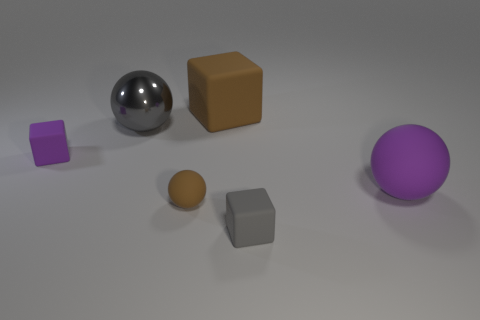Is the big object in front of the big gray sphere made of the same material as the gray thing that is in front of the big gray object?
Your answer should be compact. Yes. There is a tiny block to the right of the small cube on the left side of the small brown rubber ball; what is its material?
Your answer should be very brief. Rubber. What is the shape of the brown object behind the small rubber cube that is to the left of the block to the right of the big brown rubber cube?
Ensure brevity in your answer.  Cube. There is a tiny brown object that is the same shape as the large purple matte thing; what material is it?
Keep it short and to the point. Rubber. How many big things are there?
Make the answer very short. 3. What is the shape of the tiny thing that is in front of the tiny brown sphere?
Offer a terse response. Cube. The big ball that is right of the brown matte thing behind the brown rubber thing in front of the large matte sphere is what color?
Offer a very short reply. Purple. The gray object that is made of the same material as the purple block is what shape?
Keep it short and to the point. Cube. Are there fewer brown shiny things than brown cubes?
Provide a short and direct response. Yes. Is the tiny ball made of the same material as the gray cube?
Keep it short and to the point. Yes. 